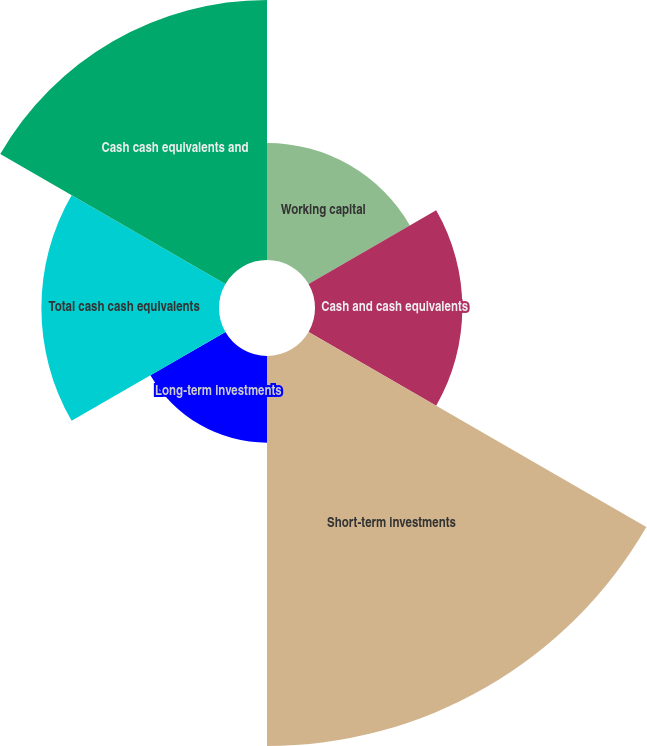Convert chart. <chart><loc_0><loc_0><loc_500><loc_500><pie_chart><fcel>Working capital<fcel>Cash and cash equivalents<fcel>Short-term investments<fcel>Long-term investments<fcel>Total cash cash equivalents<fcel>Cash cash equivalents and<nl><fcel>9.93%<fcel>12.5%<fcel>33.09%<fcel>7.35%<fcel>15.07%<fcel>22.06%<nl></chart> 